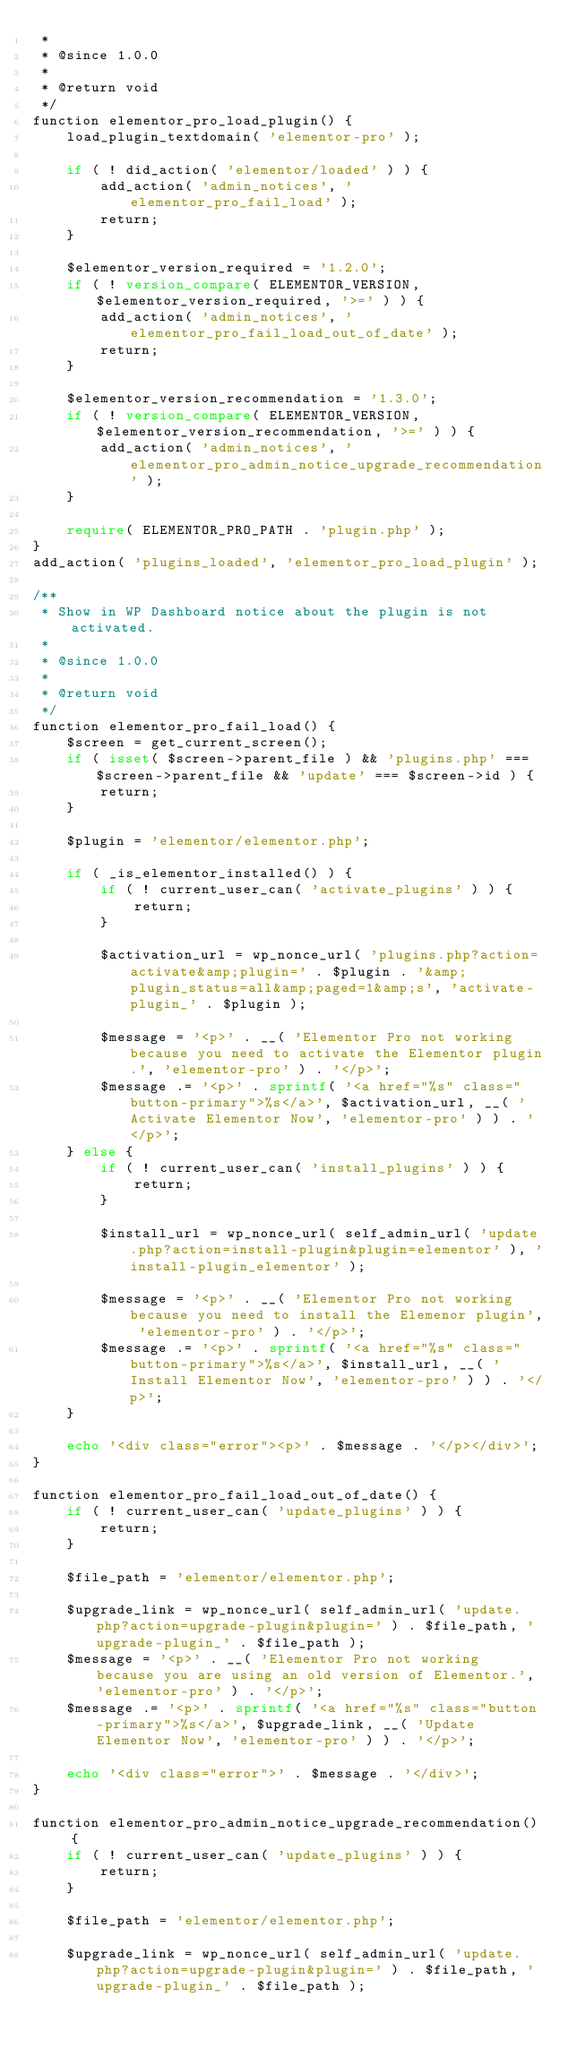<code> <loc_0><loc_0><loc_500><loc_500><_PHP_> *
 * @since 1.0.0
 *
 * @return void
 */
function elementor_pro_load_plugin() {
	load_plugin_textdomain( 'elementor-pro' );

	if ( ! did_action( 'elementor/loaded' ) ) {
		add_action( 'admin_notices', 'elementor_pro_fail_load' );
		return;
	}

	$elementor_version_required = '1.2.0';
	if ( ! version_compare( ELEMENTOR_VERSION, $elementor_version_required, '>=' ) ) {
		add_action( 'admin_notices', 'elementor_pro_fail_load_out_of_date' );
		return;
	}

	$elementor_version_recommendation = '1.3.0';
	if ( ! version_compare( ELEMENTOR_VERSION, $elementor_version_recommendation, '>=' ) ) {
		add_action( 'admin_notices', 'elementor_pro_admin_notice_upgrade_recommendation' );
	}

	require( ELEMENTOR_PRO_PATH . 'plugin.php' );
}
add_action( 'plugins_loaded', 'elementor_pro_load_plugin' );

/**
 * Show in WP Dashboard notice about the plugin is not activated.
 *
 * @since 1.0.0
 *
 * @return void
 */
function elementor_pro_fail_load() {
	$screen = get_current_screen();
	if ( isset( $screen->parent_file ) && 'plugins.php' === $screen->parent_file && 'update' === $screen->id ) {
		return;
	}

	$plugin = 'elementor/elementor.php';

	if ( _is_elementor_installed() ) {
		if ( ! current_user_can( 'activate_plugins' ) ) {
			return;
		}

		$activation_url = wp_nonce_url( 'plugins.php?action=activate&amp;plugin=' . $plugin . '&amp;plugin_status=all&amp;paged=1&amp;s', 'activate-plugin_' . $plugin );

		$message = '<p>' . __( 'Elementor Pro not working because you need to activate the Elementor plugin.', 'elementor-pro' ) . '</p>';
		$message .= '<p>' . sprintf( '<a href="%s" class="button-primary">%s</a>', $activation_url, __( 'Activate Elementor Now', 'elementor-pro' ) ) . '</p>';
	} else {
		if ( ! current_user_can( 'install_plugins' ) ) {
			return;
		}

		$install_url = wp_nonce_url( self_admin_url( 'update.php?action=install-plugin&plugin=elementor' ), 'install-plugin_elementor' );

		$message = '<p>' . __( 'Elementor Pro not working because you need to install the Elemenor plugin', 'elementor-pro' ) . '</p>';
		$message .= '<p>' . sprintf( '<a href="%s" class="button-primary">%s</a>', $install_url, __( 'Install Elementor Now', 'elementor-pro' ) ) . '</p>';
	}

	echo '<div class="error"><p>' . $message . '</p></div>';
}

function elementor_pro_fail_load_out_of_date() {
	if ( ! current_user_can( 'update_plugins' ) ) {
		return;
	}

	$file_path = 'elementor/elementor.php';

	$upgrade_link = wp_nonce_url( self_admin_url( 'update.php?action=upgrade-plugin&plugin=' ) . $file_path, 'upgrade-plugin_' . $file_path );
	$message = '<p>' . __( 'Elementor Pro not working because you are using an old version of Elementor.', 'elementor-pro' ) . '</p>';
	$message .= '<p>' . sprintf( '<a href="%s" class="button-primary">%s</a>', $upgrade_link, __( 'Update Elementor Now', 'elementor-pro' ) ) . '</p>';

	echo '<div class="error">' . $message . '</div>';
}

function elementor_pro_admin_notice_upgrade_recommendation() {
	if ( ! current_user_can( 'update_plugins' ) ) {
		return;
	}

	$file_path = 'elementor/elementor.php';

	$upgrade_link = wp_nonce_url( self_admin_url( 'update.php?action=upgrade-plugin&plugin=' ) . $file_path, 'upgrade-plugin_' . $file_path );</code> 